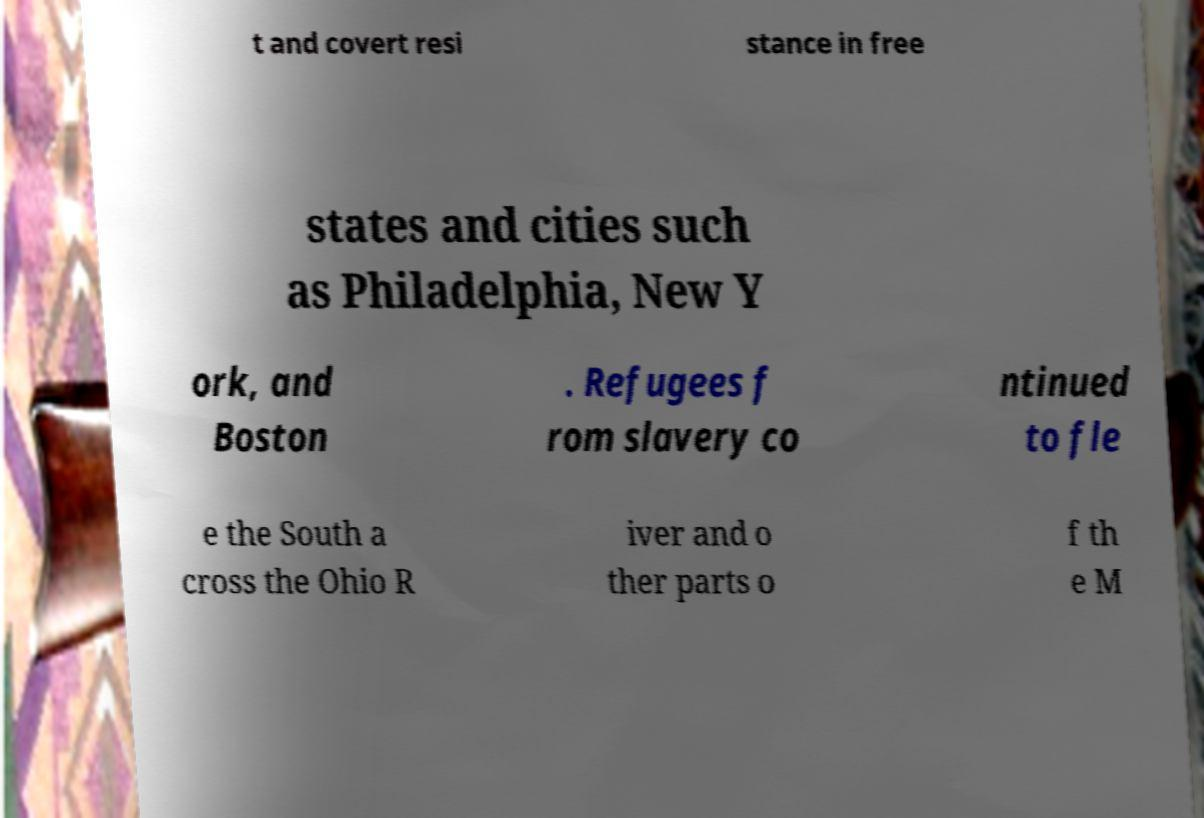Please identify and transcribe the text found in this image. t and covert resi stance in free states and cities such as Philadelphia, New Y ork, and Boston . Refugees f rom slavery co ntinued to fle e the South a cross the Ohio R iver and o ther parts o f th e M 